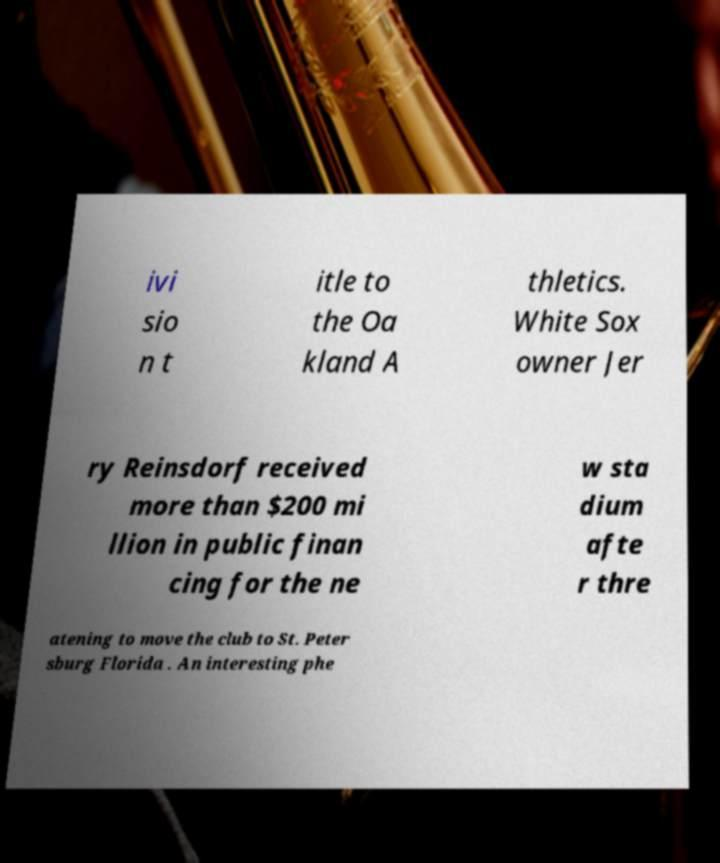For documentation purposes, I need the text within this image transcribed. Could you provide that? ivi sio n t itle to the Oa kland A thletics. White Sox owner Jer ry Reinsdorf received more than $200 mi llion in public finan cing for the ne w sta dium afte r thre atening to move the club to St. Peter sburg Florida . An interesting phe 